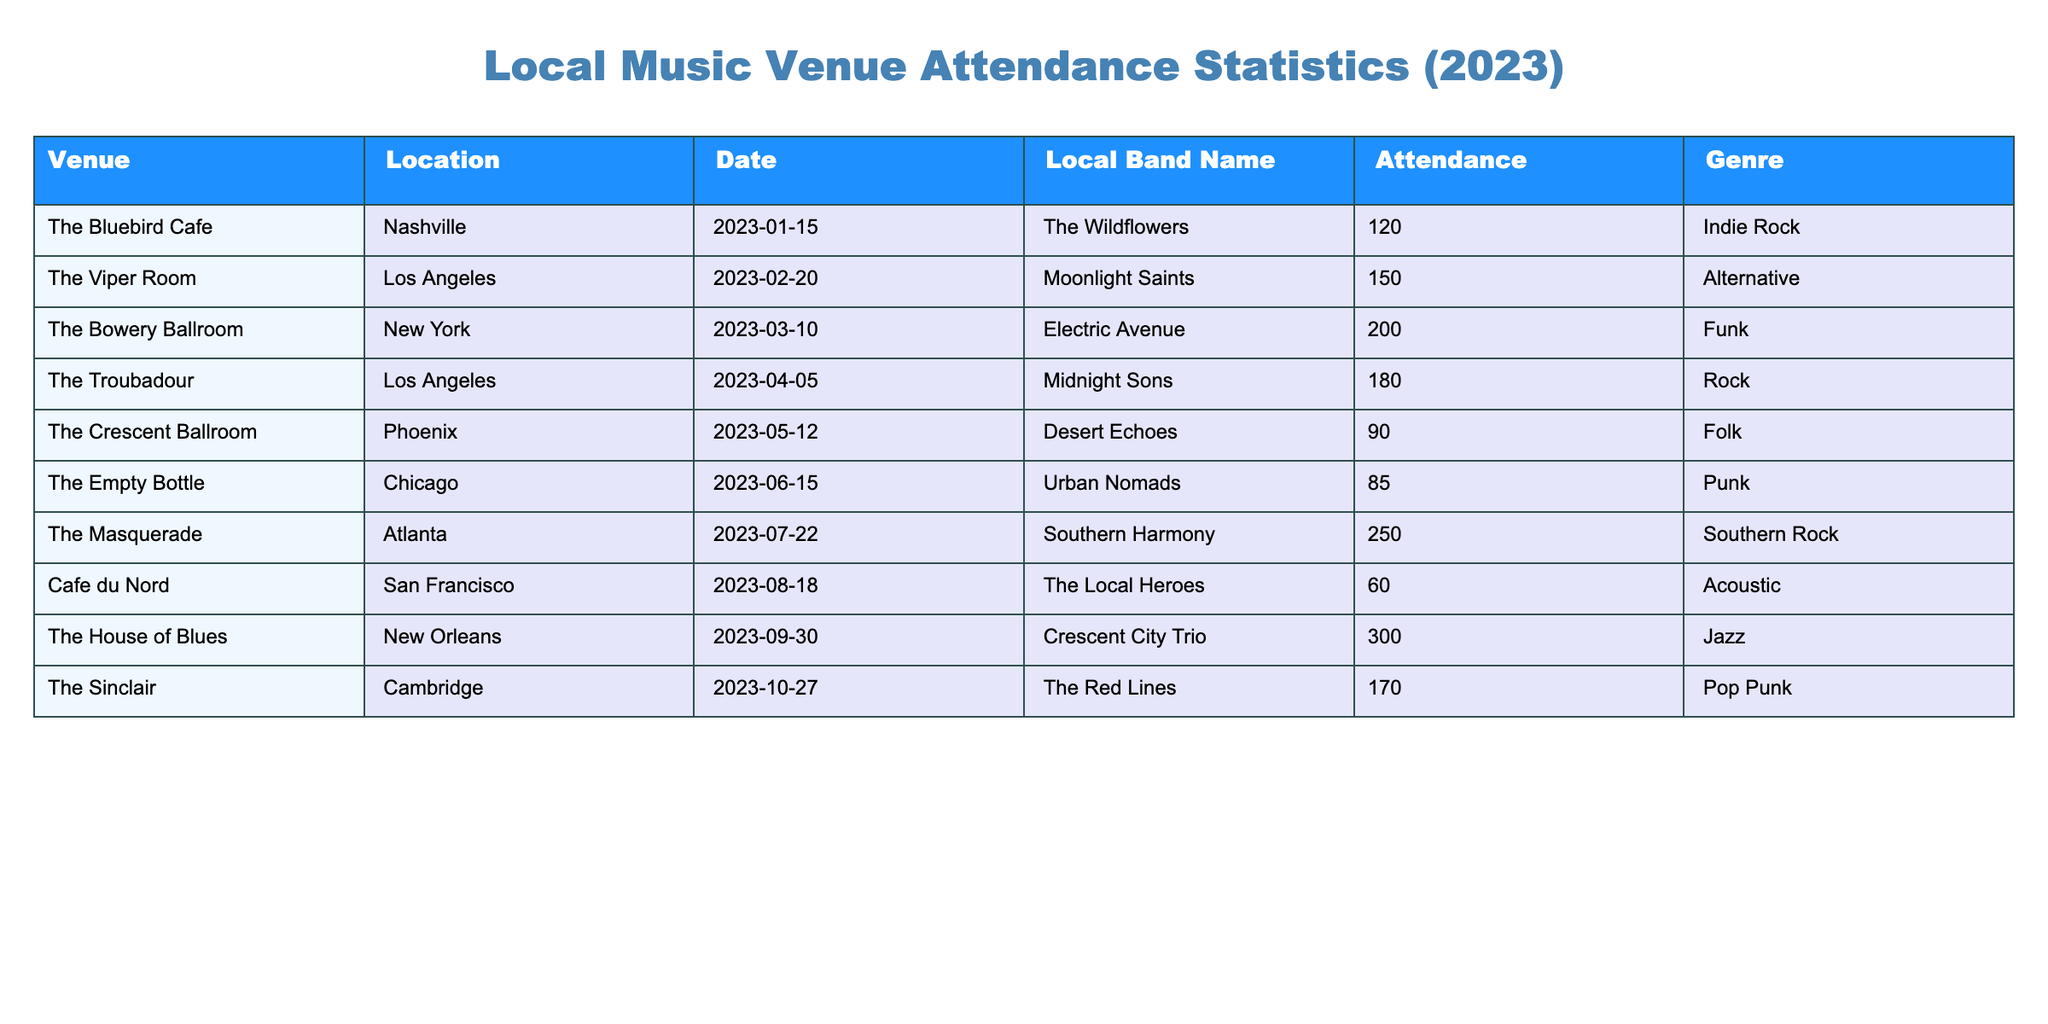What is the highest attendance recorded in the table? The table lists the attendance figures for various local bands. Looking at the "Attendance" column, the maximum value is 300, corresponding to the Crescent City Trio at The House of Blues in New Orleans.
Answer: 300 Which city had a local band with the lowest attendance? Comparing the attendance numbers in the table, the lowest attendance is 60 at Cafe du Nord in San Francisco for The Local Heroes.
Answer: San Francisco What is the total attendance for all events mentioned in the table? To find the total attendance, add up all the attendance figures: 120 + 150 + 200 + 180 + 90 + 85 + 250 + 60 + 300 + 170 = 1,605.
Answer: 1605 How many local bands had an attendance over 150? Reviewing the attendance numbers, the bands with over 150 attendees are: Moonlight Saints (150), Electric Avenue (200), Midnight Sons (180), Southern Harmony (250), and Crescent City Trio (300). This makes a total of 5 bands.
Answer: 5 Is it true that all bands listed belong to different music genres? Checking the "Genre" column, we can see that some genres repeat among different bands (like various bands listed under rock). Therefore, it is false that all bands belong to different genres.
Answer: No What is the average attendance for indie rock bands? From the table, there is one indie rock band, The Wildflowers, with an attendance of 120. Since there is only one band, the average attendance is the same as that of the single band: 120.
Answer: 120 Which venue had the most attendees and what was the genre? The venue with the highest attendance is The House of Blues in New Orleans, with 300 attendees, and the genre is Jazz.
Answer: The House of Blues, Jazz What is the difference in attendance between the band with the highest and lowest attendance? The highest attendance is 300 (Crescent City Trio), and the lowest attendance is 60 (The Local Heroes). The difference is calculated as 300 - 60 = 240.
Answer: 240 How many different genres are represented among the performances? By analyzing the "Genre" column, we identify the genres: Indie Rock, Alternative, Funk, Rock, Folk, Punk, Southern Rock, Acoustic, Jazz, and Pop Punk, which totals to 10 different genres.
Answer: 10 